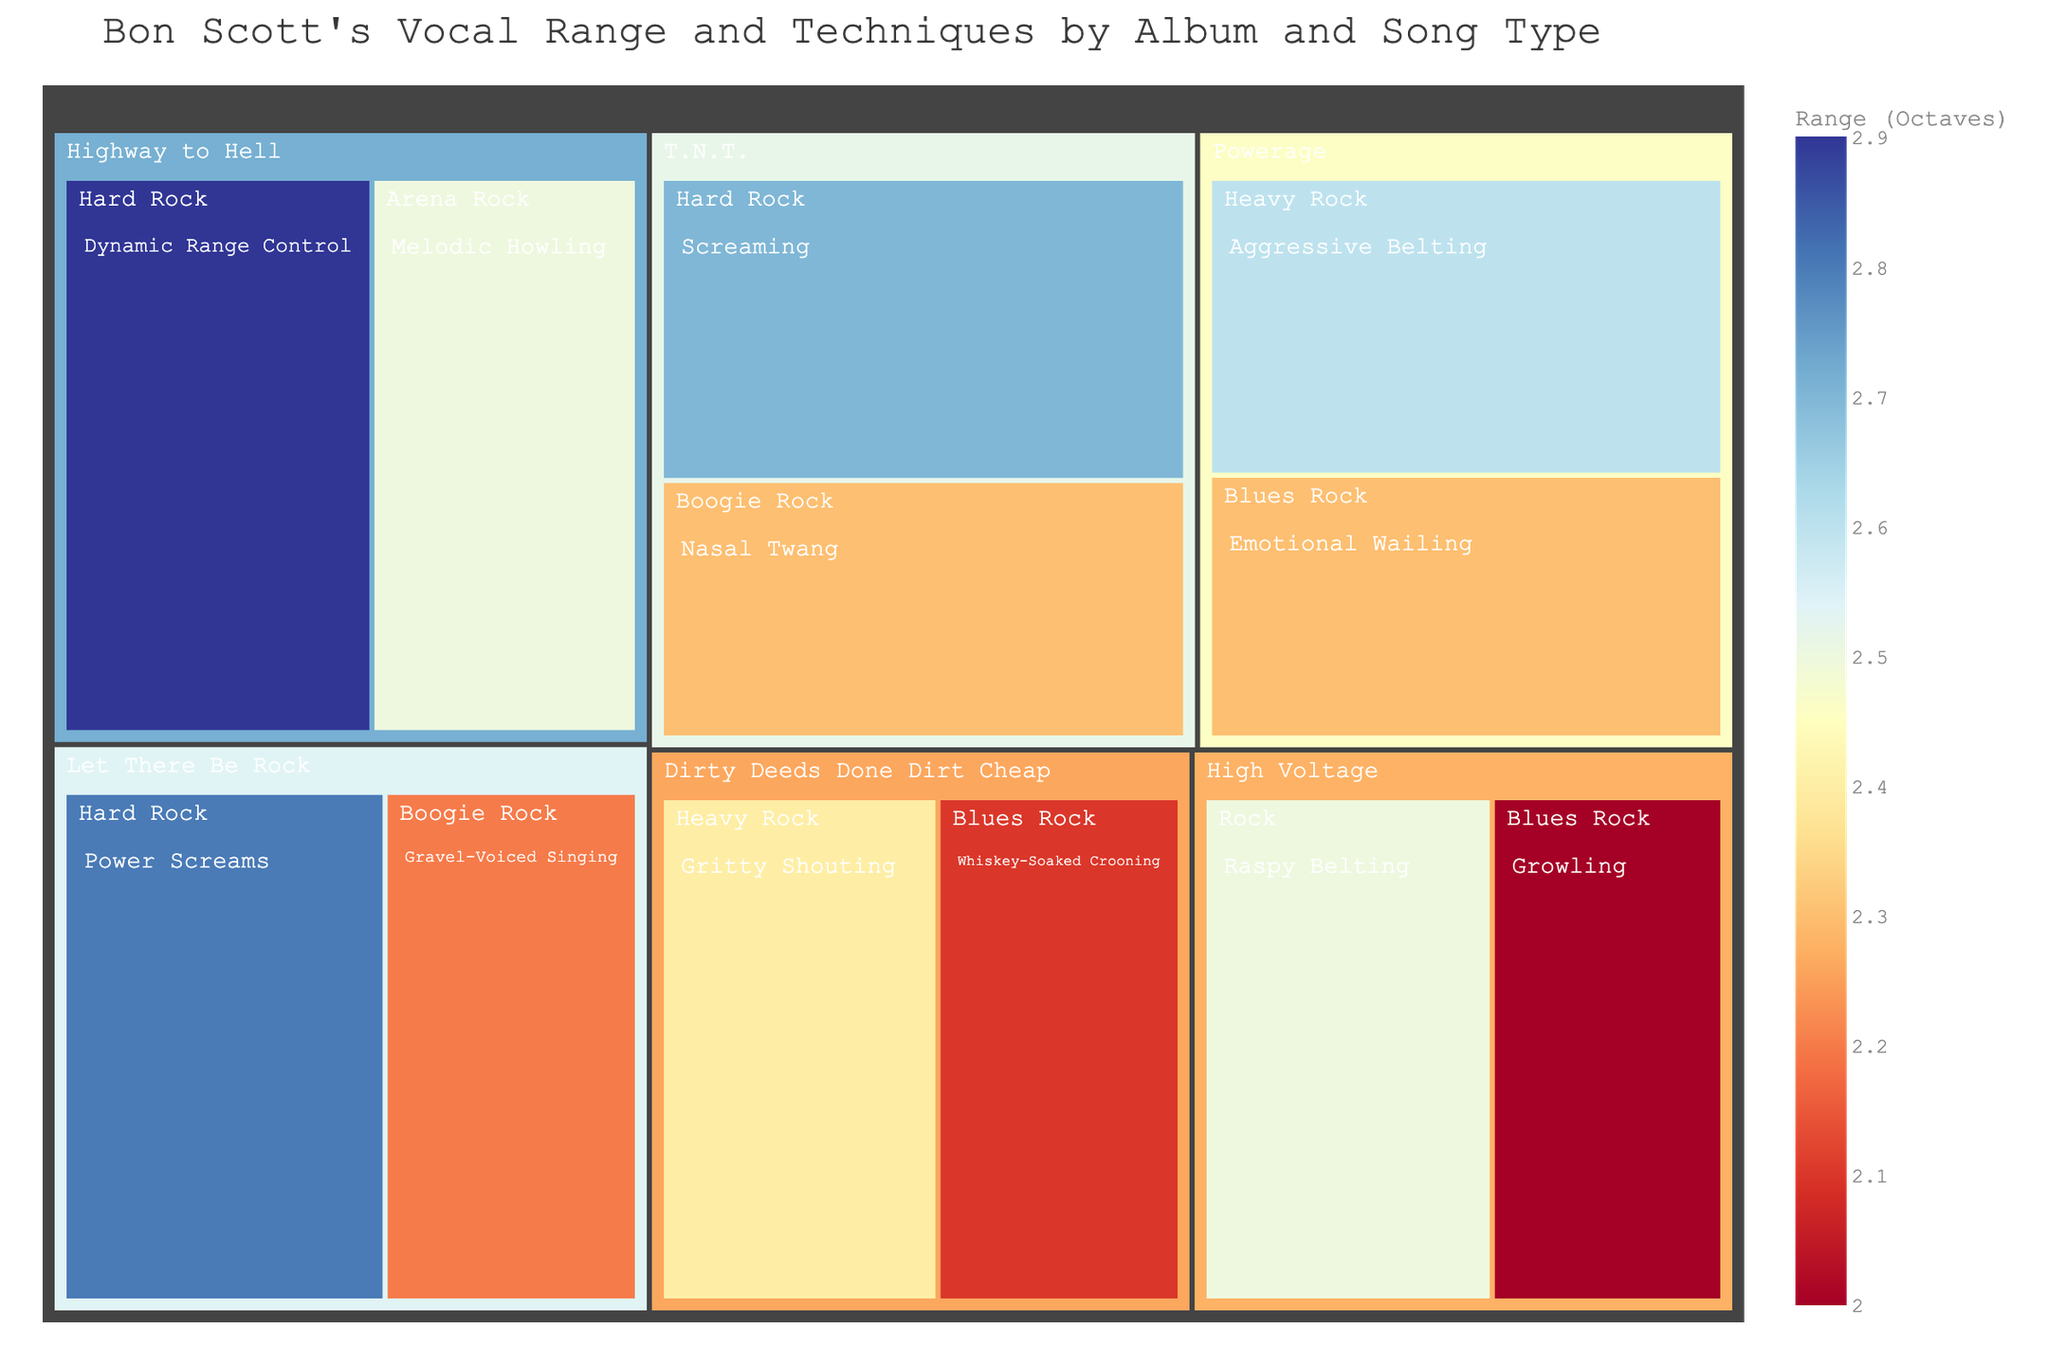How many vocal techniques are represented in the 'High Voltage' album? Look at the Treemap and locate the 'High Voltage' album section, which divides into 'Rock' and 'Blues Rock', then check for distinct vocal techniques within these song types.
Answer: 2 Which album has the highest vocal range documented in the figure? Identify the vocal range values in the Treemap associated with each album and select the highest value, which occurs under the 'Highway to Hell' album with 'Dynamic Range Control' at 2.9 octaves.
Answer: Highway to Hell What is the total number of unique vocal techniques illustrated across all albums? Count all unique names of vocal techniques in the Treemap, avoiding repetitions. The techniques are: Raspy Belting, Growling, Screaming, Nasal Twang, Gritty Shouting, Whiskey-Soaked Crooning, Power Screams, Gravel-Voiced Singing, Aggressive Belting, Emotional Wailing, Dynamic Range Control, and Melodic Howling.
Answer: 12 Which song type in the 'Powerage' album features the highest vocal range? Look for the song types under 'Powerage' and observe their respective vocal range values. Identify the highest value, which belongs to 'Heavy Rock' with 'Aggressive Belting' at 2.6 octaves.
Answer: Heavy Rock Compare the vocal ranges of 'Blues Rock' tracks across different albums, which album features the blues rock song with the highest vocal range? Examine the vocal range values of 'Blues Rock' songs from different albums. The highest value is from the 'Powerage' album with 'Emotional Wailing' having a range of 2.3 octaves.
Answer: Powerage 